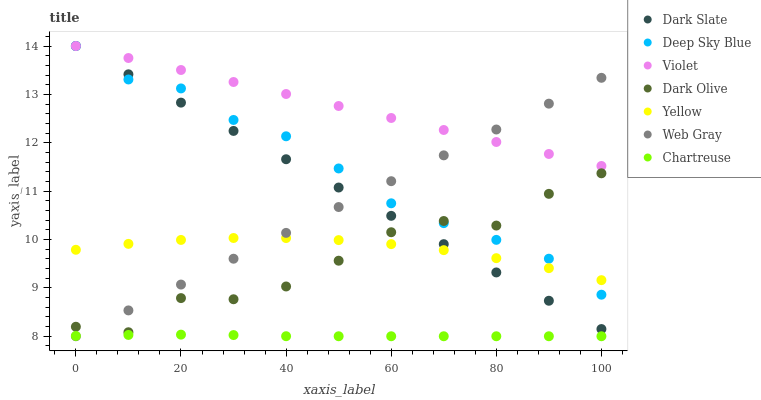Does Chartreuse have the minimum area under the curve?
Answer yes or no. Yes. Does Violet have the maximum area under the curve?
Answer yes or no. Yes. Does Dark Olive have the minimum area under the curve?
Answer yes or no. No. Does Dark Olive have the maximum area under the curve?
Answer yes or no. No. Is Web Gray the smoothest?
Answer yes or no. Yes. Is Dark Olive the roughest?
Answer yes or no. Yes. Is Yellow the smoothest?
Answer yes or no. No. Is Yellow the roughest?
Answer yes or no. No. Does Web Gray have the lowest value?
Answer yes or no. Yes. Does Dark Olive have the lowest value?
Answer yes or no. No. Does Violet have the highest value?
Answer yes or no. Yes. Does Dark Olive have the highest value?
Answer yes or no. No. Is Chartreuse less than Yellow?
Answer yes or no. Yes. Is Violet greater than Yellow?
Answer yes or no. Yes. Does Dark Slate intersect Dark Olive?
Answer yes or no. Yes. Is Dark Slate less than Dark Olive?
Answer yes or no. No. Is Dark Slate greater than Dark Olive?
Answer yes or no. No. Does Chartreuse intersect Yellow?
Answer yes or no. No. 